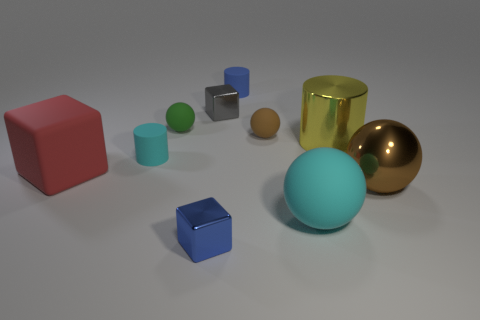Subtract all brown rubber spheres. How many spheres are left? 3 Subtract all brown balls. How many balls are left? 2 Subtract all cylinders. How many objects are left? 7 Add 2 tiny green objects. How many tiny green objects exist? 3 Subtract 0 purple cylinders. How many objects are left? 10 Subtract 2 blocks. How many blocks are left? 1 Subtract all gray cubes. Subtract all yellow cylinders. How many cubes are left? 2 Subtract all brown cylinders. How many brown balls are left? 2 Subtract all tiny rubber cylinders. Subtract all large rubber cubes. How many objects are left? 7 Add 7 small cyan rubber cylinders. How many small cyan rubber cylinders are left? 8 